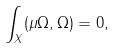<formula> <loc_0><loc_0><loc_500><loc_500>\int _ { X } ( \mu \Omega , \Omega ) = 0 ,</formula> 